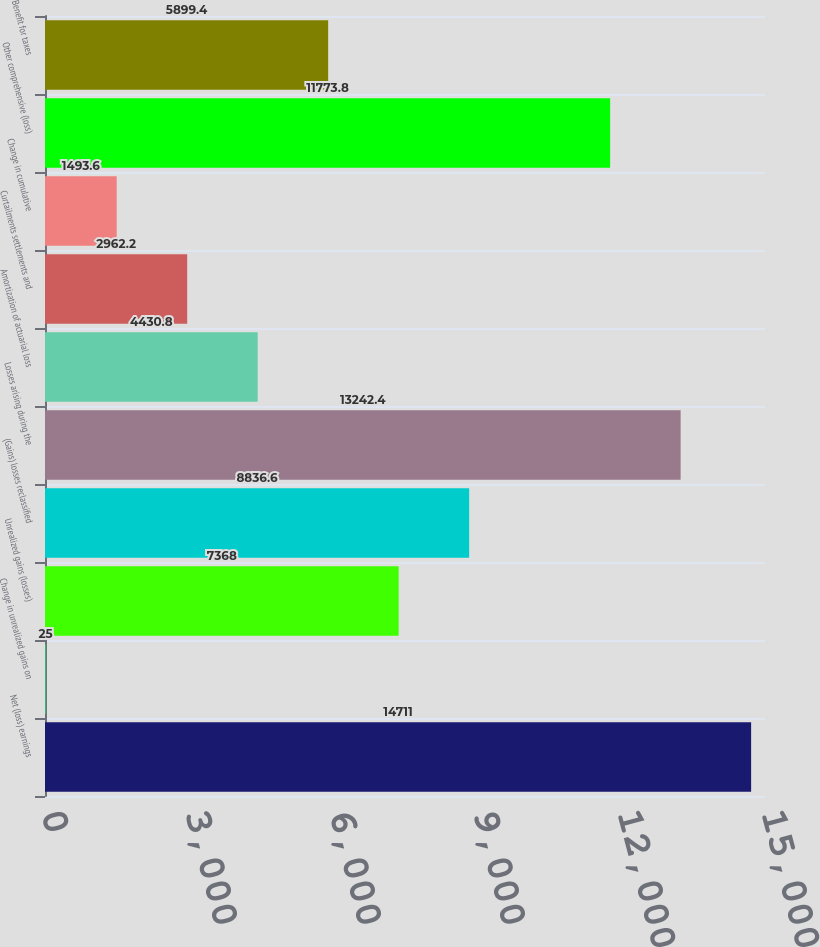<chart> <loc_0><loc_0><loc_500><loc_500><bar_chart><fcel>Net (loss) earnings<fcel>Change in unrealized gains on<fcel>Unrealized gains (losses)<fcel>(Gains) losses reclassified<fcel>Losses arising during the<fcel>Amortization of actuarial loss<fcel>Curtailments settlements and<fcel>Change in cumulative<fcel>Other comprehensive (loss)<fcel>Benefit for taxes<nl><fcel>14711<fcel>25<fcel>7368<fcel>8836.6<fcel>13242.4<fcel>4430.8<fcel>2962.2<fcel>1493.6<fcel>11773.8<fcel>5899.4<nl></chart> 